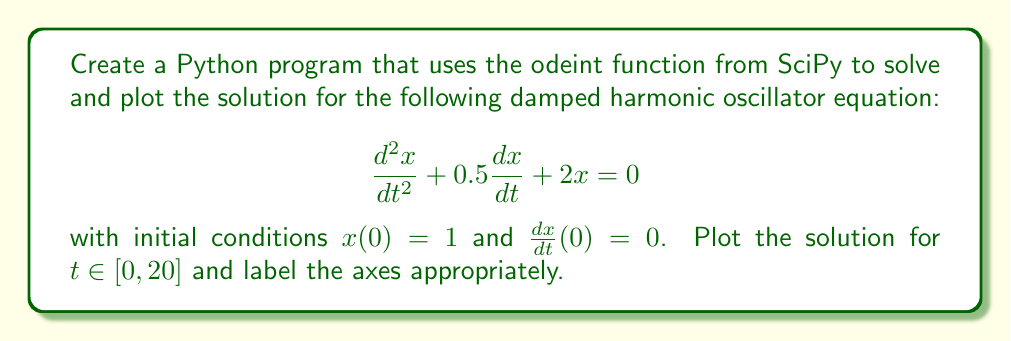Give your solution to this math problem. To solve this problem using Python and the odeint function from SciPy, we need to follow these steps:

1. Import necessary libraries:
   ```python
   import numpy as np
   from scipy.integrate import odeint
   import matplotlib.pyplot as plt
   ```

2. Define the system of first-order ODEs:
   The second-order ODE needs to be converted into a system of two first-order ODEs. Let $y = \frac{dx}{dt}$, then:
   $$ \frac{dx}{dt} = y $$
   $$ \frac{dy}{dt} = -0.5y - 2x $$

   We can represent this system as a function in Python:
   ```python
   def model(state, t):
       x, y = state
       dxdt = y
       dydt = -0.5 * y - 2 * x
       return [dxdt, dydt]
   ```

3. Set up initial conditions and time array:
   ```python
   initial_state = [1, 0]  # x(0) = 1, dx/dt(0) = 0
   t = np.linspace(0, 20, 1000)
   ```

4. Solve the ODE using odeint:
   ```python
   solution = odeint(model, initial_state, t)
   ```

5. Plot the solution:
   ```python
   plt.figure(figsize=(10, 6))
   plt.plot(t, solution[:, 0], 'b', label='x(t)')
   plt.xlabel('Time')
   plt.ylabel('x')
   plt.title('Damped Harmonic Oscillator')
   plt.legend()
   plt.grid(True)
   plt.show()
   ```

The complete Python code would look like this:

```python
import numpy as np
from scipy.integrate import odeint
import matplotlib.pyplot as plt

def model(state, t):
    x, y = state
    dxdt = y
    dydt = -0.5 * y - 2 * x
    return [dxdt, dydt]

initial_state = [1, 0]
t = np.linspace(0, 20, 1000)

solution = odeint(model, initial_state, t)

plt.figure(figsize=(10, 6))
plt.plot(t, solution[:, 0], 'b', label='x(t)')
plt.xlabel('Time')
plt.ylabel('x')
plt.title('Damped Harmonic Oscillator')
plt.legend()
plt.grid(True)
plt.show()
```

This code will produce a plot showing the solution $x(t)$ of the damped harmonic oscillator equation.
Answer: The answer is the complete Python code provided in the explanation, which solves and plots the solution for the given damped harmonic oscillator equation using the odeint function from SciPy. 